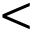Convert formula to latex. <formula><loc_0><loc_0><loc_500><loc_500><</formula> 